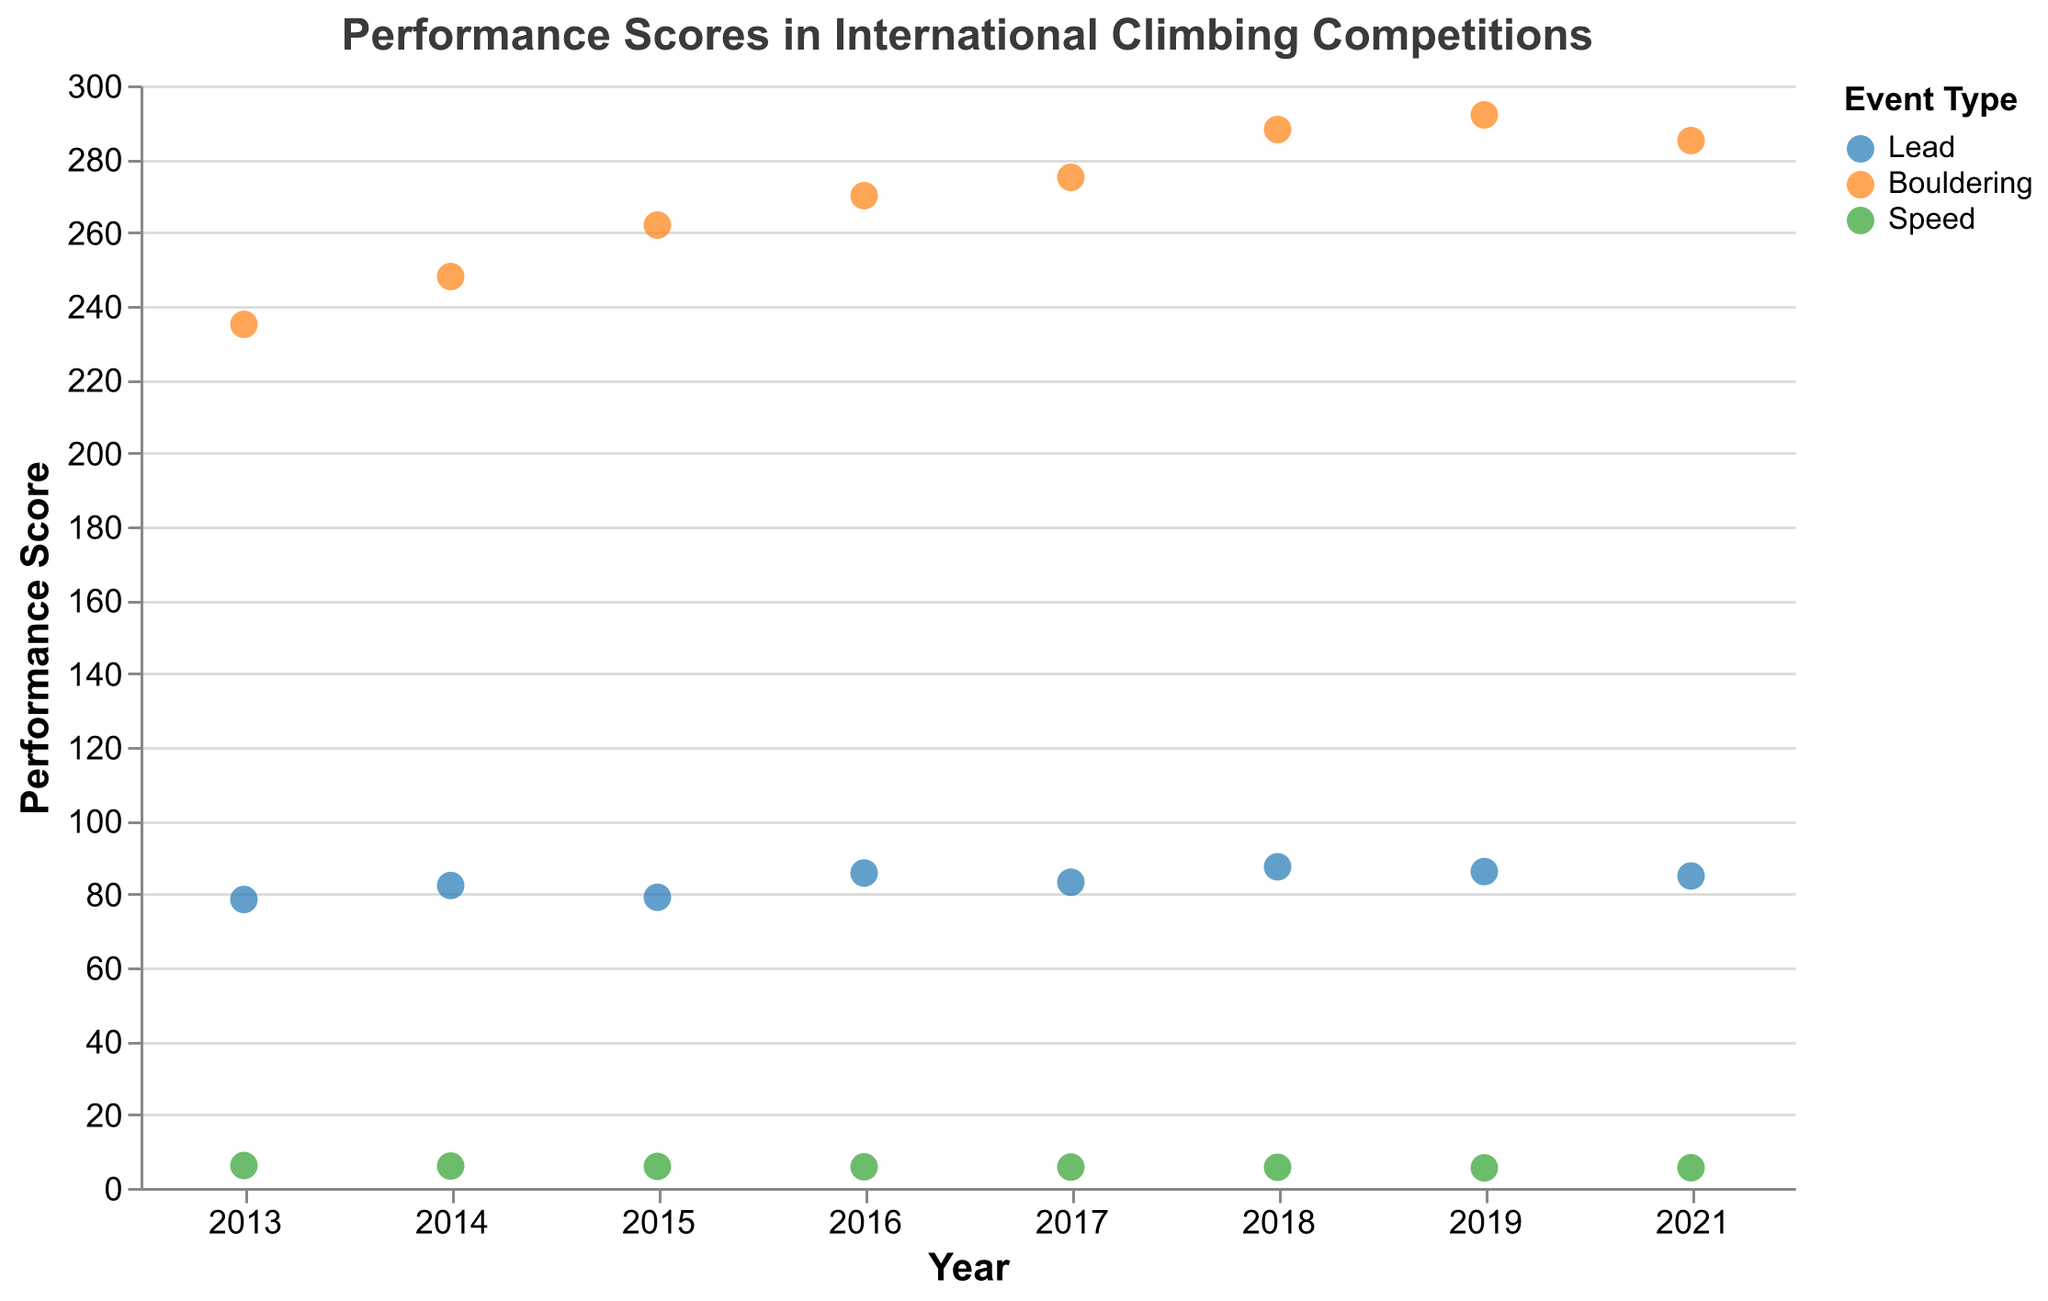What is the title of the plot? The title is located at the top of the plot and reads "Performance Scores in International Climbing Competitions".
Answer: Performance Scores in International Climbing Competitions How many different colors are used to represent the event types in the plot? The plot uses three different colors to represent three event types: Lead, Bouldering, and Speed. These can be identified by the three distinct colors in the plot.
Answer: Three Which event has the highest score in 2018 and who is the climber? By observing the scores for 2018, we see that Bouldering has the highest score of 288, achieved by Janja Garnbret.
Answer: Bouldering, Janja Garnbret What is the trend in Speed climbing scores from 2013 to 2021? Looking at the data points for Speed from 2013 to 2021, the scores progressively decrease from 6.12 to 5.51, indicating an improvement in speed as lower times are better.
Answer: Scores are decreasing Compare the highest scores in Lead and Bouldering events in 2019. What is the difference between them? In 2019, the highest score in Lead is 86.1 (Janja Garnbret), and in Bouldering, it is 292 (Adam Ondra). The difference is 292 - 86.1 = 205.9.
Answer: 205.9 Which event shows the most improvement over the observed period? By comparing the starting and ending scores for each event type over the years, we see that Speed shows the most improvement, as the time reduced from 6.12 in 2013 to 5.51 in 2021.
Answer: Speed Who has the highest score in the Lead event over the period and what is the score? Checking the highest scores within the Lead event, Adam Ondra achieves the highest score of 87.4 in 2018.
Answer: Adam Ondra, 87.4 Is there any event type where the climber with the highest score has the same score across multiple years? By observing the scores, it is clear that no climber in any event type holds the highest score with the same numerical value across multiple years.
Answer: No How many data points are present for each event type? Counting the data points within each category: Lead has 8, Bouldering has 8, and Speed has 8 data points based on the yearly distribution.
Answer: Eight for each event type What is the average score for Bouldering in the years where Janja Garnbret participated? Janja Garnbret participated in Bouldering in 2018 and her score is 288. Since it’s only one year, the average score remains 288.
Answer: 288 